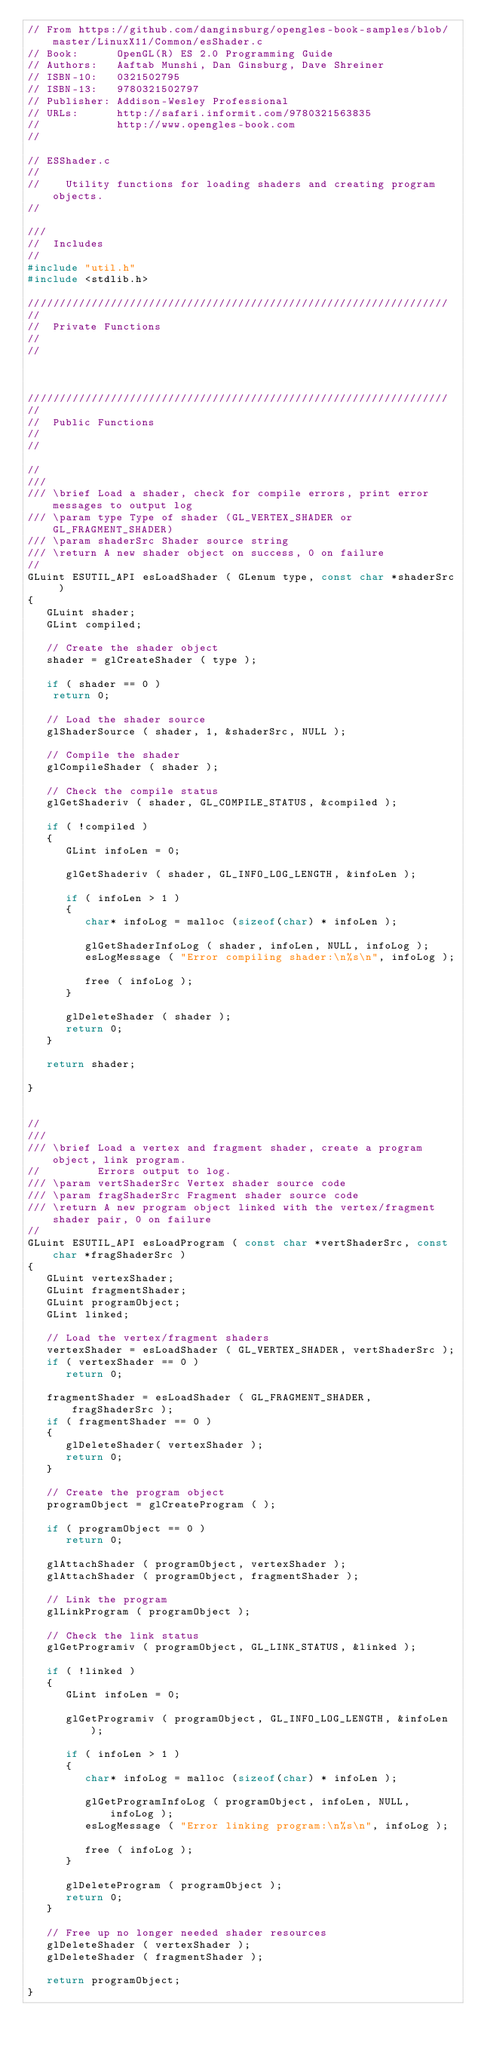Convert code to text. <code><loc_0><loc_0><loc_500><loc_500><_C_>// From https://github.com/danginsburg/opengles-book-samples/blob/master/LinuxX11/Common/esShader.c
// Book:      OpenGL(R) ES 2.0 Programming Guide
// Authors:   Aaftab Munshi, Dan Ginsburg, Dave Shreiner
// ISBN-10:   0321502795
// ISBN-13:   9780321502797
// Publisher: Addison-Wesley Professional
// URLs:      http://safari.informit.com/9780321563835
//            http://www.opengles-book.com
//

// ESShader.c
//
//    Utility functions for loading shaders and creating program objects.
//

///
//  Includes
//
#include "util.h"
#include <stdlib.h>

//////////////////////////////////////////////////////////////////
//
//  Private Functions
//
//



//////////////////////////////////////////////////////////////////
//
//  Public Functions
//
//

//
///
/// \brief Load a shader, check for compile errors, print error messages to output log
/// \param type Type of shader (GL_VERTEX_SHADER or GL_FRAGMENT_SHADER)
/// \param shaderSrc Shader source string
/// \return A new shader object on success, 0 on failure
//
GLuint ESUTIL_API esLoadShader ( GLenum type, const char *shaderSrc )
{
   GLuint shader;
   GLint compiled;
   
   // Create the shader object
   shader = glCreateShader ( type );

   if ( shader == 0 )
   	return 0;

   // Load the shader source
   glShaderSource ( shader, 1, &shaderSrc, NULL );
   
   // Compile the shader
   glCompileShader ( shader );

   // Check the compile status
   glGetShaderiv ( shader, GL_COMPILE_STATUS, &compiled );

   if ( !compiled ) 
   {
      GLint infoLen = 0;

      glGetShaderiv ( shader, GL_INFO_LOG_LENGTH, &infoLen );
      
      if ( infoLen > 1 )
      {
         char* infoLog = malloc (sizeof(char) * infoLen );

         glGetShaderInfoLog ( shader, infoLen, NULL, infoLog );
         esLogMessage ( "Error compiling shader:\n%s\n", infoLog );            
         
         free ( infoLog );
      }

      glDeleteShader ( shader );
      return 0;
   }

   return shader;

}


//
///
/// \brief Load a vertex and fragment shader, create a program object, link program.
//         Errors output to log.
/// \param vertShaderSrc Vertex shader source code
/// \param fragShaderSrc Fragment shader source code
/// \return A new program object linked with the vertex/fragment shader pair, 0 on failure
//
GLuint ESUTIL_API esLoadProgram ( const char *vertShaderSrc, const char *fragShaderSrc )
{
   GLuint vertexShader;
   GLuint fragmentShader;
   GLuint programObject;
   GLint linked;

   // Load the vertex/fragment shaders
   vertexShader = esLoadShader ( GL_VERTEX_SHADER, vertShaderSrc );
   if ( vertexShader == 0 )
      return 0;

   fragmentShader = esLoadShader ( GL_FRAGMENT_SHADER, fragShaderSrc );
   if ( fragmentShader == 0 )
   {
      glDeleteShader( vertexShader );
      return 0;
   }

   // Create the program object
   programObject = glCreateProgram ( );
   
   if ( programObject == 0 )
      return 0;

   glAttachShader ( programObject, vertexShader );
   glAttachShader ( programObject, fragmentShader );

   // Link the program
   glLinkProgram ( programObject );

   // Check the link status
   glGetProgramiv ( programObject, GL_LINK_STATUS, &linked );

   if ( !linked ) 
   {
      GLint infoLen = 0;

      glGetProgramiv ( programObject, GL_INFO_LOG_LENGTH, &infoLen );
      
      if ( infoLen > 1 )
      {
         char* infoLog = malloc (sizeof(char) * infoLen );

         glGetProgramInfoLog ( programObject, infoLen, NULL, infoLog );
         esLogMessage ( "Error linking program:\n%s\n", infoLog );            
         
         free ( infoLog );
      }

      glDeleteProgram ( programObject );
      return 0;
   }

   // Free up no longer needed shader resources
   glDeleteShader ( vertexShader );
   glDeleteShader ( fragmentShader );

   return programObject;
}</code> 